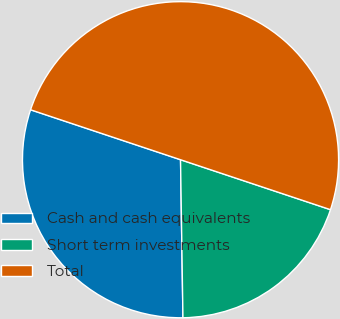<chart> <loc_0><loc_0><loc_500><loc_500><pie_chart><fcel>Cash and cash equivalents<fcel>Short term investments<fcel>Total<nl><fcel>30.36%<fcel>19.64%<fcel>50.0%<nl></chart> 